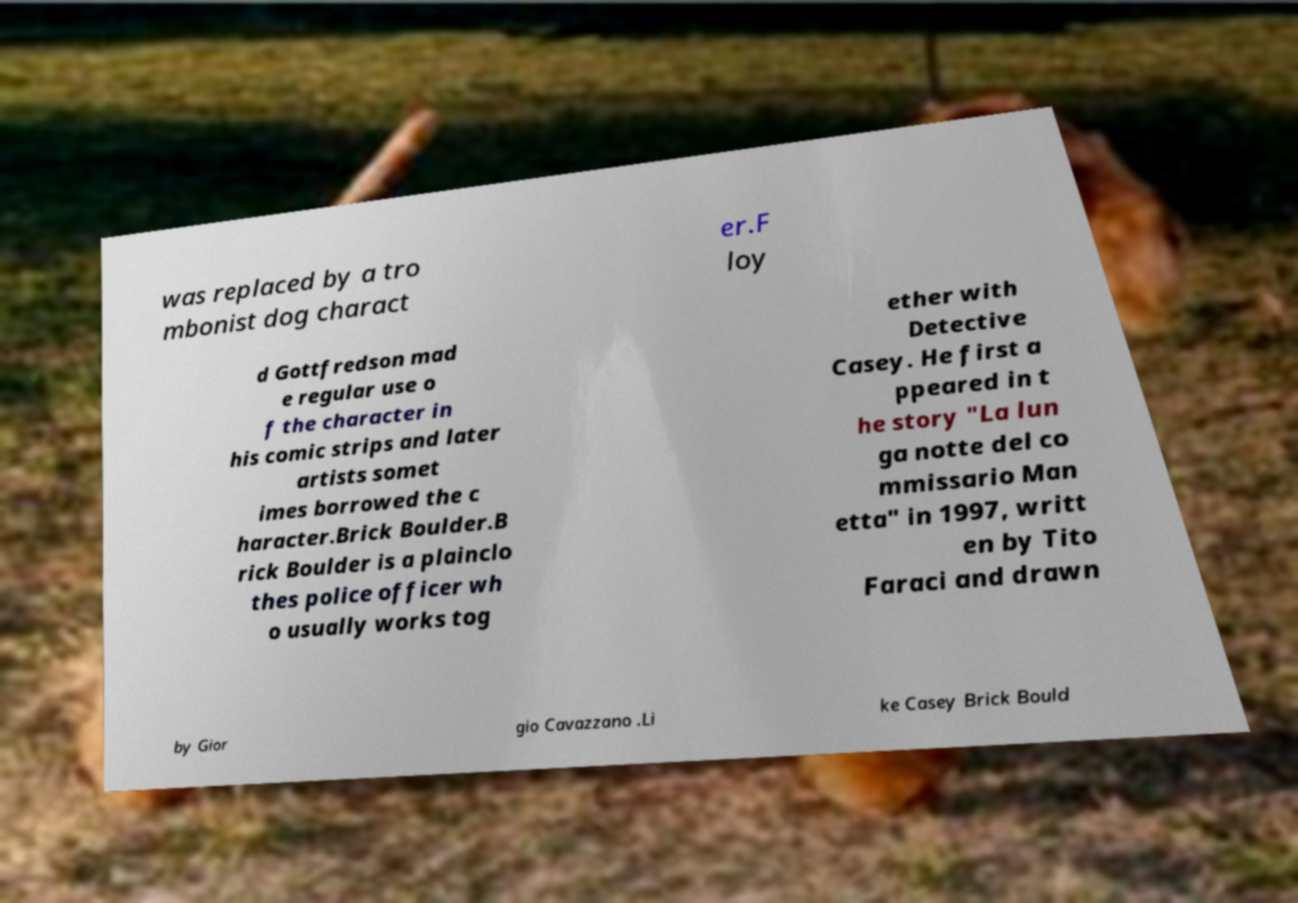For documentation purposes, I need the text within this image transcribed. Could you provide that? was replaced by a tro mbonist dog charact er.F loy d Gottfredson mad e regular use o f the character in his comic strips and later artists somet imes borrowed the c haracter.Brick Boulder.B rick Boulder is a plainclo thes police officer wh o usually works tog ether with Detective Casey. He first a ppeared in t he story "La lun ga notte del co mmissario Man etta" in 1997, writt en by Tito Faraci and drawn by Gior gio Cavazzano .Li ke Casey Brick Bould 